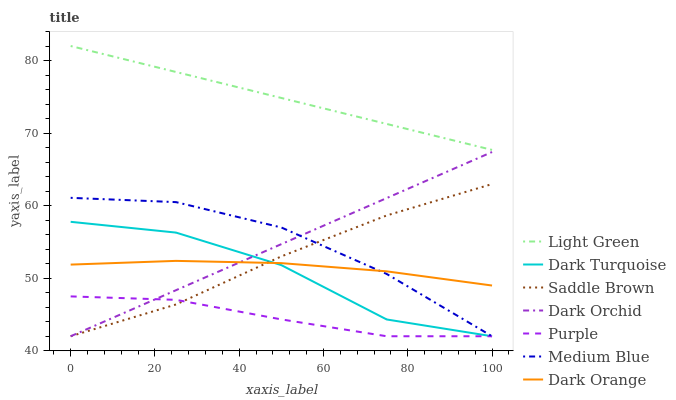Does Purple have the minimum area under the curve?
Answer yes or no. Yes. Does Light Green have the maximum area under the curve?
Answer yes or no. Yes. Does Dark Turquoise have the minimum area under the curve?
Answer yes or no. No. Does Dark Turquoise have the maximum area under the curve?
Answer yes or no. No. Is Dark Orchid the smoothest?
Answer yes or no. Yes. Is Dark Turquoise the roughest?
Answer yes or no. Yes. Is Purple the smoothest?
Answer yes or no. No. Is Purple the roughest?
Answer yes or no. No. Does Purple have the lowest value?
Answer yes or no. Yes. Does Light Green have the lowest value?
Answer yes or no. No. Does Light Green have the highest value?
Answer yes or no. Yes. Does Dark Turquoise have the highest value?
Answer yes or no. No. Is Purple less than Dark Orange?
Answer yes or no. Yes. Is Light Green greater than Saddle Brown?
Answer yes or no. Yes. Does Dark Turquoise intersect Medium Blue?
Answer yes or no. Yes. Is Dark Turquoise less than Medium Blue?
Answer yes or no. No. Is Dark Turquoise greater than Medium Blue?
Answer yes or no. No. Does Purple intersect Dark Orange?
Answer yes or no. No. 